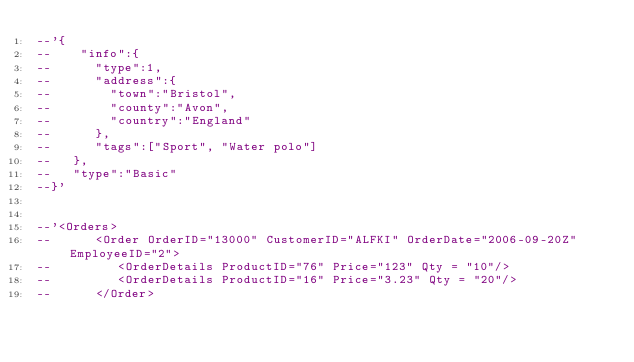<code> <loc_0><loc_0><loc_500><loc_500><_SQL_>--'{
--    "info":{  
--      "type":1,
--      "address":{  
--        "town":"Bristol",
--        "county":"Avon",
--        "country":"England"
--      },
--      "tags":["Sport", "Water polo"]
--   },
--   "type":"Basic"
--}'


--'<Orders>
--      <Order OrderID="13000" CustomerID="ALFKI" OrderDate="2006-09-20Z" EmployeeID="2">
--         <OrderDetails ProductID="76" Price="123" Qty = "10"/>
--         <OrderDetails ProductID="16" Price="3.23" Qty = "20"/>
--      </Order></code> 